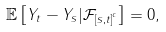<formula> <loc_0><loc_0><loc_500><loc_500>\mathbb { E } \left [ Y _ { t } - Y _ { s } | \mathcal { F } _ { \left [ s , t \right ] ^ { c } } \right ] = 0 ,</formula> 